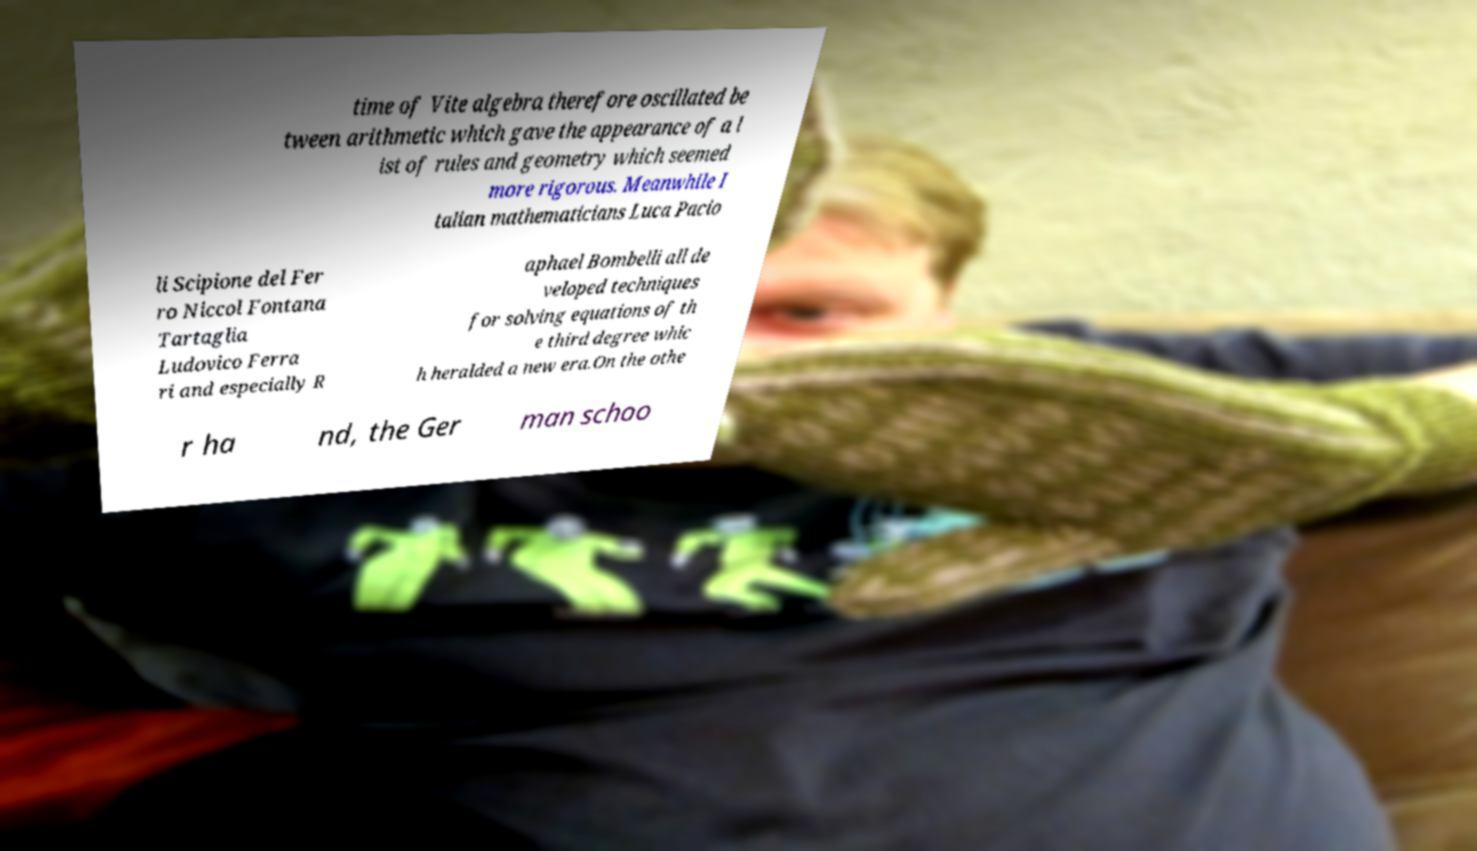For documentation purposes, I need the text within this image transcribed. Could you provide that? time of Vite algebra therefore oscillated be tween arithmetic which gave the appearance of a l ist of rules and geometry which seemed more rigorous. Meanwhile I talian mathematicians Luca Pacio li Scipione del Fer ro Niccol Fontana Tartaglia Ludovico Ferra ri and especially R aphael Bombelli all de veloped techniques for solving equations of th e third degree whic h heralded a new era.On the othe r ha nd, the Ger man schoo 